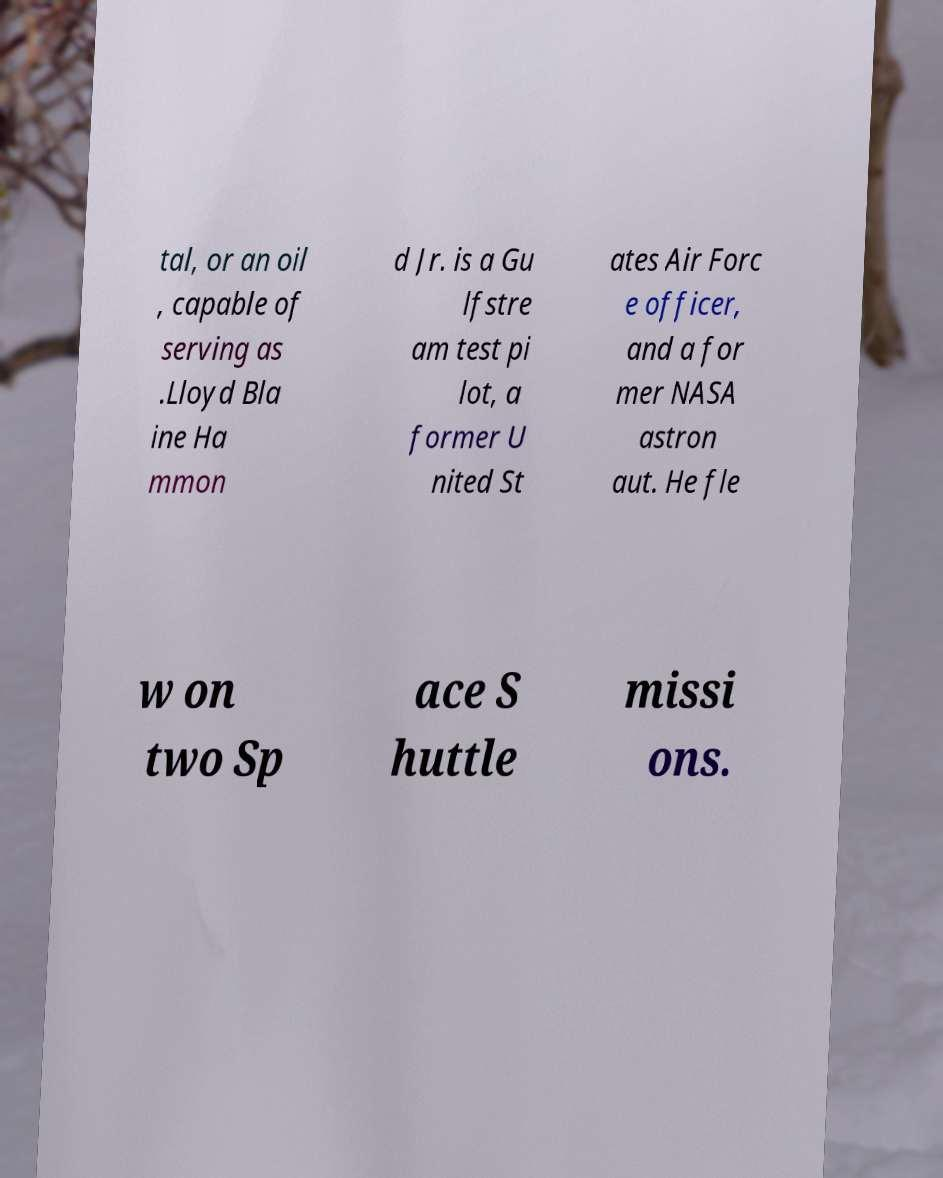Could you extract and type out the text from this image? tal, or an oil , capable of serving as .Lloyd Bla ine Ha mmon d Jr. is a Gu lfstre am test pi lot, a former U nited St ates Air Forc e officer, and a for mer NASA astron aut. He fle w on two Sp ace S huttle missi ons. 